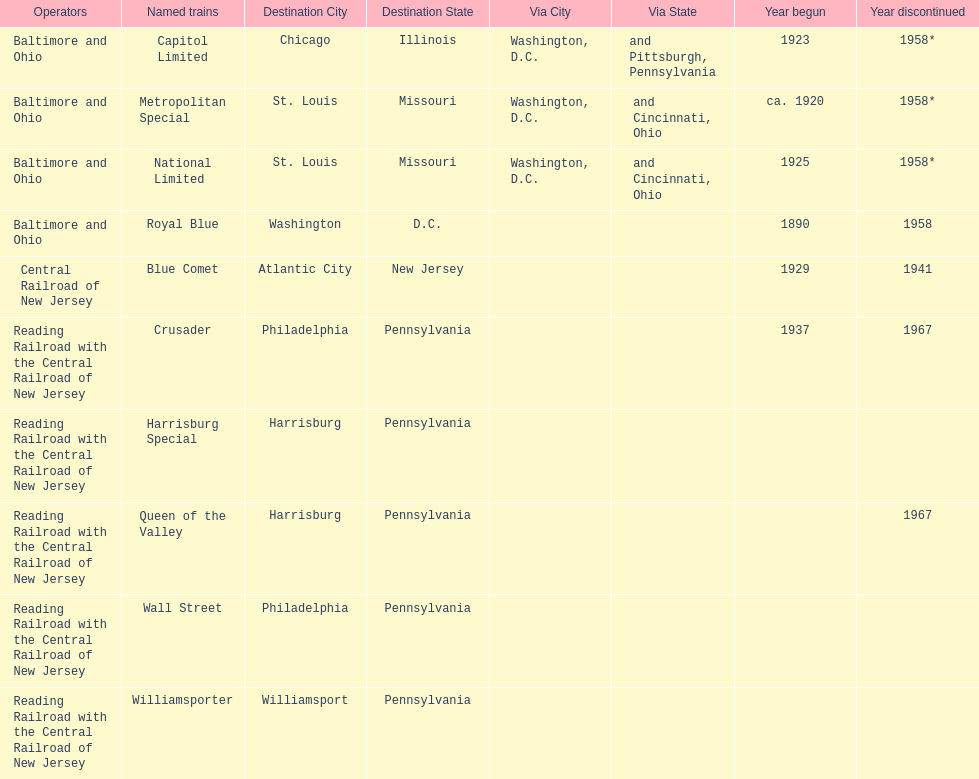What destination is at the top of the list? Chicago, Illinois via Washington, D.C. and Pittsburgh, Pennsylvania. 